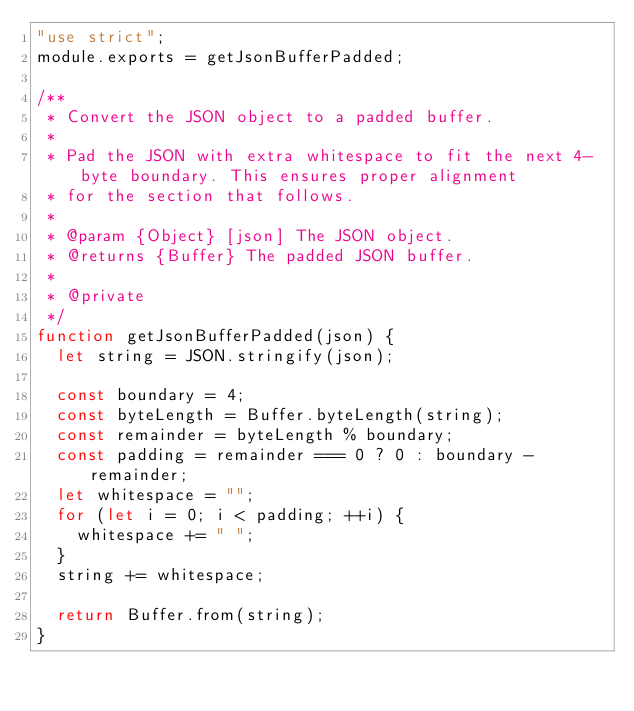Convert code to text. <code><loc_0><loc_0><loc_500><loc_500><_JavaScript_>"use strict";
module.exports = getJsonBufferPadded;

/**
 * Convert the JSON object to a padded buffer.
 *
 * Pad the JSON with extra whitespace to fit the next 4-byte boundary. This ensures proper alignment
 * for the section that follows.
 *
 * @param {Object} [json] The JSON object.
 * @returns {Buffer} The padded JSON buffer.
 *
 * @private
 */
function getJsonBufferPadded(json) {
  let string = JSON.stringify(json);

  const boundary = 4;
  const byteLength = Buffer.byteLength(string);
  const remainder = byteLength % boundary;
  const padding = remainder === 0 ? 0 : boundary - remainder;
  let whitespace = "";
  for (let i = 0; i < padding; ++i) {
    whitespace += " ";
  }
  string += whitespace;

  return Buffer.from(string);
}
</code> 